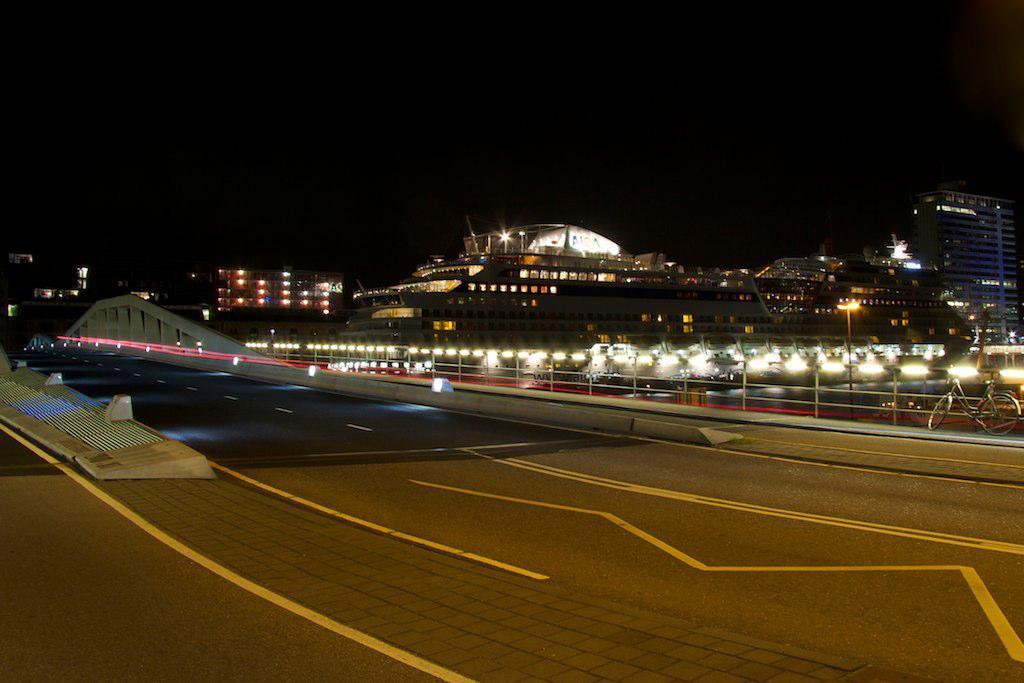Describe this image in one or two sentences. In this image we can see there are buildings with lights and we can see the bicycle near the fence. And there are stones, wall, railing, road and dark background. 